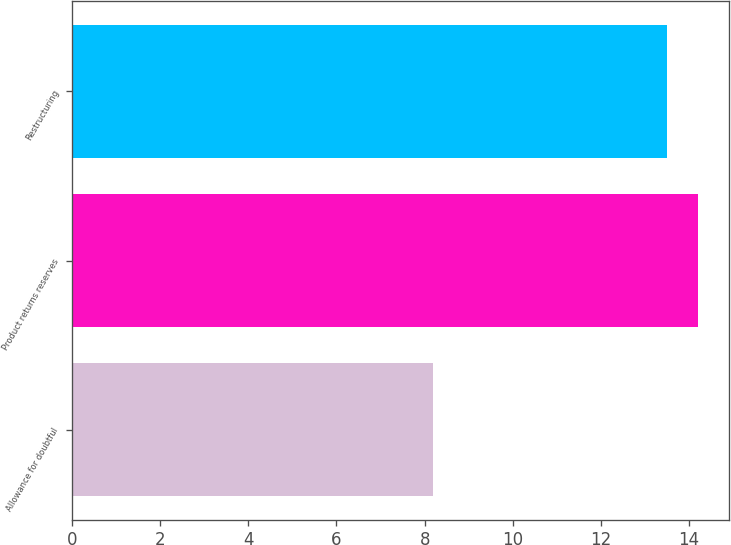Convert chart to OTSL. <chart><loc_0><loc_0><loc_500><loc_500><bar_chart><fcel>Allowance for doubtful<fcel>Product returns reserves<fcel>Restructuring<nl><fcel>8.2<fcel>14.2<fcel>13.5<nl></chart> 